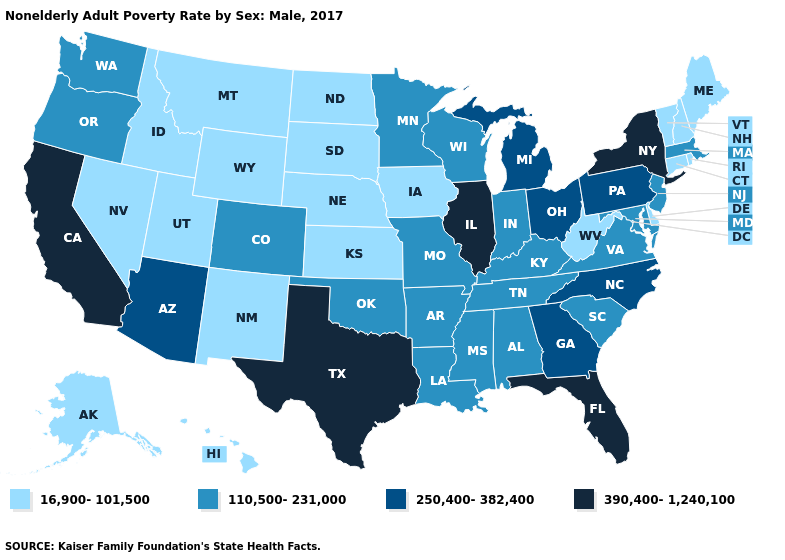Name the states that have a value in the range 16,900-101,500?
Concise answer only. Alaska, Connecticut, Delaware, Hawaii, Idaho, Iowa, Kansas, Maine, Montana, Nebraska, Nevada, New Hampshire, New Mexico, North Dakota, Rhode Island, South Dakota, Utah, Vermont, West Virginia, Wyoming. What is the value of Alabama?
Write a very short answer. 110,500-231,000. What is the value of California?
Answer briefly. 390,400-1,240,100. What is the value of Vermont?
Quick response, please. 16,900-101,500. Does New Mexico have the highest value in the West?
Write a very short answer. No. Which states hav the highest value in the MidWest?
Concise answer only. Illinois. Name the states that have a value in the range 250,400-382,400?
Write a very short answer. Arizona, Georgia, Michigan, North Carolina, Ohio, Pennsylvania. What is the value of Virginia?
Short answer required. 110,500-231,000. Name the states that have a value in the range 250,400-382,400?
Give a very brief answer. Arizona, Georgia, Michigan, North Carolina, Ohio, Pennsylvania. What is the highest value in the USA?
Be succinct. 390,400-1,240,100. Name the states that have a value in the range 110,500-231,000?
Give a very brief answer. Alabama, Arkansas, Colorado, Indiana, Kentucky, Louisiana, Maryland, Massachusetts, Minnesota, Mississippi, Missouri, New Jersey, Oklahoma, Oregon, South Carolina, Tennessee, Virginia, Washington, Wisconsin. Name the states that have a value in the range 16,900-101,500?
Give a very brief answer. Alaska, Connecticut, Delaware, Hawaii, Idaho, Iowa, Kansas, Maine, Montana, Nebraska, Nevada, New Hampshire, New Mexico, North Dakota, Rhode Island, South Dakota, Utah, Vermont, West Virginia, Wyoming. Does New York have a lower value than New Hampshire?
Give a very brief answer. No. Name the states that have a value in the range 390,400-1,240,100?
Give a very brief answer. California, Florida, Illinois, New York, Texas. 